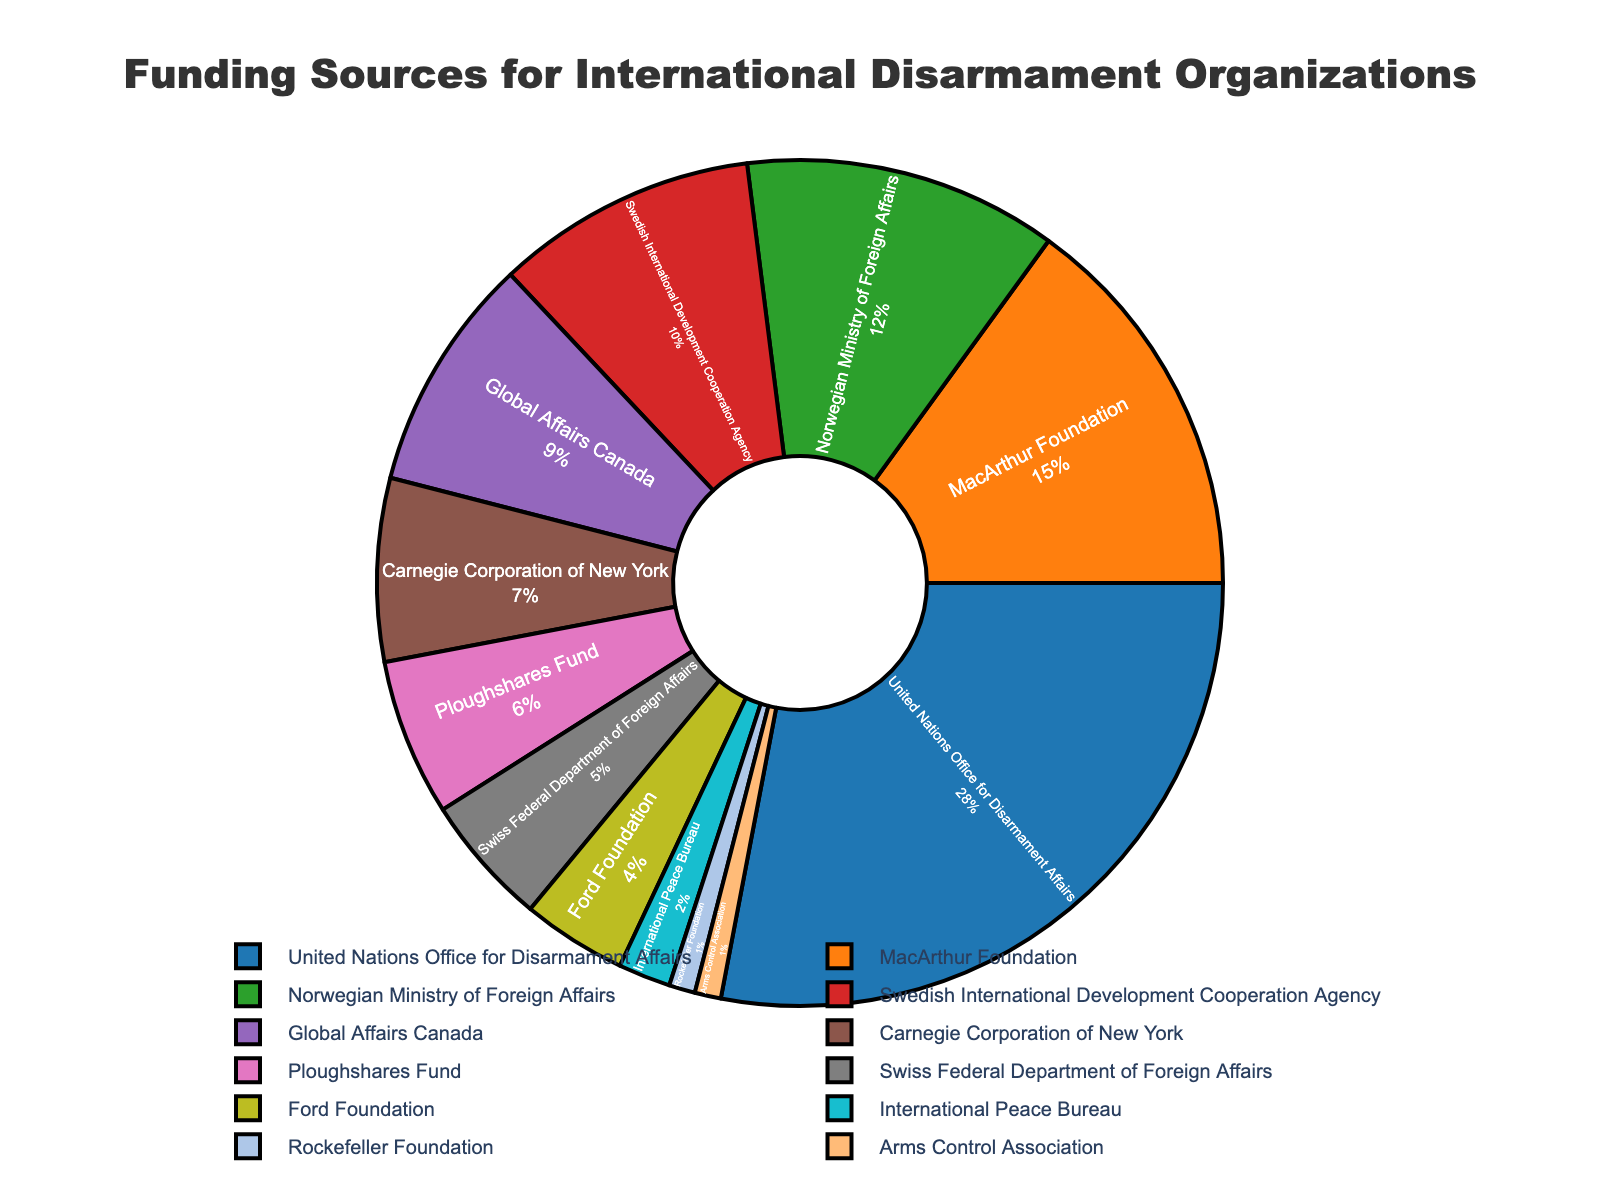Which funding source contributes the highest percentage? The United Nations Office for Disarmament Affairs provides the largest percentage slice in the pie chart. Identifying the largest segment indicates this.
Answer: United Nations Office for Disarmament Affairs Which funding source has the smallest percentage? The Rockefeller Foundation and Arms Control Association each account for the smallest percentage slice in the pie chart. The labels show they both have the least contribution.
Answer: Rockefeller Foundation and Arms Control Association What is the combined percentage of the United Nations Office for Disarmament Affairs and the MacArthur Foundation? The United Nations Office for Disarmament Affairs has a 28% contribution, and the MacArthur Foundation has a 15% contribution. Summing these gives 28% + 15%.
Answer: 43% Which funding source has a higher percentage, the Norwegian Ministry of Foreign Affairs or the Global Affairs Canada? The Norwegian Ministry of Foreign Affairs has a 12% contribution, while Global Affairs Canada has 9%. Comparing these two percentages, 12% is greater than 9%.
Answer: Norwegian Ministry of Foreign Affairs What is the percentage difference between the Swedish International Development Cooperation Agency and the Ploughshares Fund? The Swedish International Development Cooperation Agency has a 10% contribution, and the Ploughshares Fund has 6%. The difference is 10% - 6%.
Answer: 4% What is the average percentage contribution of the top four funding sources? The top four funding sources are: United Nations Office for Disarmament Affairs (28%), MacArthur Foundation (15%), Norwegian Ministry of Foreign Affairs (12%), and Swedish International Development Cooperation Agency (10%). Summing these percentages and dividing by 4 gives (28% + 15% + 12% + 10%)/4.
Answer: 16.25% By which percentage does the contribution of the Carnegie Corporation of New York exceed that of the Ford Foundation? The Carnegie Corporation of New York has a 7% contribution, and the Ford Foundation has 4%. The difference is 7% - 4%.
Answer: 3% Which funding sources have a combined contribution percentage equal to the United Nations Office for Disarmament Affairs? The United Nations Office for Disarmament Affairs contributes 28%, so the combined percentage of MacArthur Foundation (15%) and Swedish International Development Cooperation Agency (10%) adding a smaller percentage might give a match. Summing these three, 15% + 10% + 3% = 28%.
Answer: MacArthur Foundation, Swedish International Development Cooperation Agency, and Ploughshares Fund 